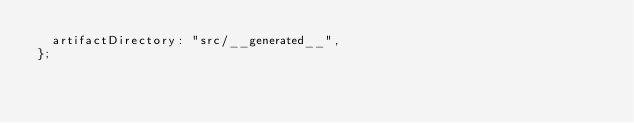Convert code to text. <code><loc_0><loc_0><loc_500><loc_500><_JavaScript_>  artifactDirectory: "src/__generated__",
};
</code> 